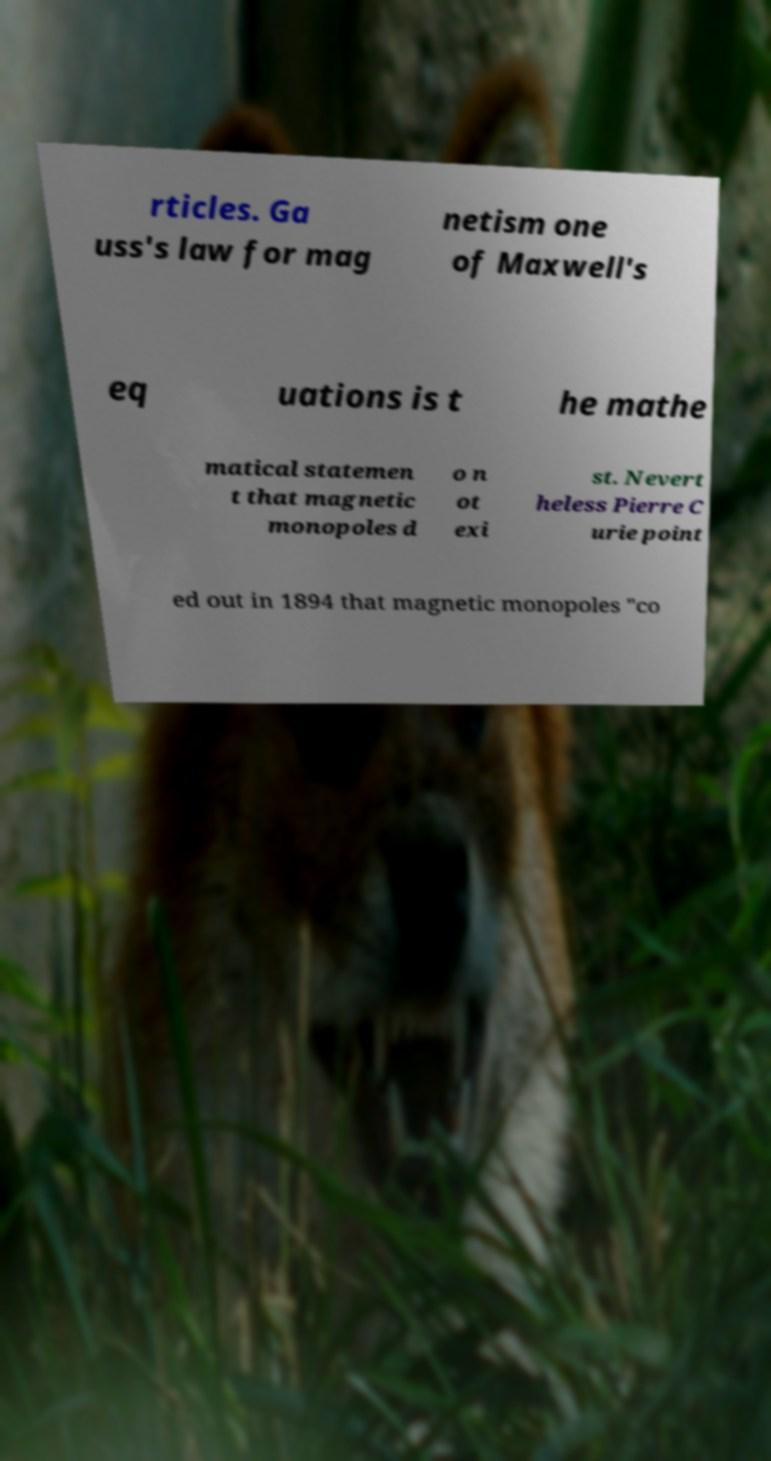Please read and relay the text visible in this image. What does it say? rticles. Ga uss's law for mag netism one of Maxwell's eq uations is t he mathe matical statemen t that magnetic monopoles d o n ot exi st. Nevert heless Pierre C urie point ed out in 1894 that magnetic monopoles "co 